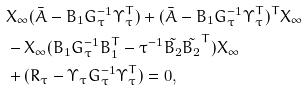<formula> <loc_0><loc_0><loc_500><loc_500>& X _ { \infty } ( \bar { A } - B _ { 1 } G _ { \tau } ^ { - 1 } \Upsilon _ { \tau } ^ { T } ) + ( \bar { A } - B _ { 1 } G _ { \tau } ^ { - 1 } \Upsilon _ { \tau } ^ { T } ) ^ { T } X _ { \infty } \\ & - X _ { \infty } ( B _ { 1 } G _ { \tau } ^ { - 1 } B _ { 1 } ^ { T } - \tau ^ { - 1 } \tilde { B _ { 2 } } \tilde { B _ { 2 } } ^ { T } ) X _ { \infty } \\ & + ( R _ { \tau } - \Upsilon _ { \tau } G _ { \tau } ^ { - 1 } \Upsilon _ { \tau } ^ { T } ) = 0 ,</formula> 